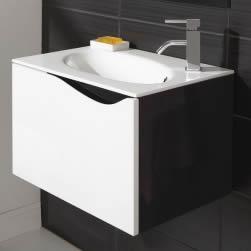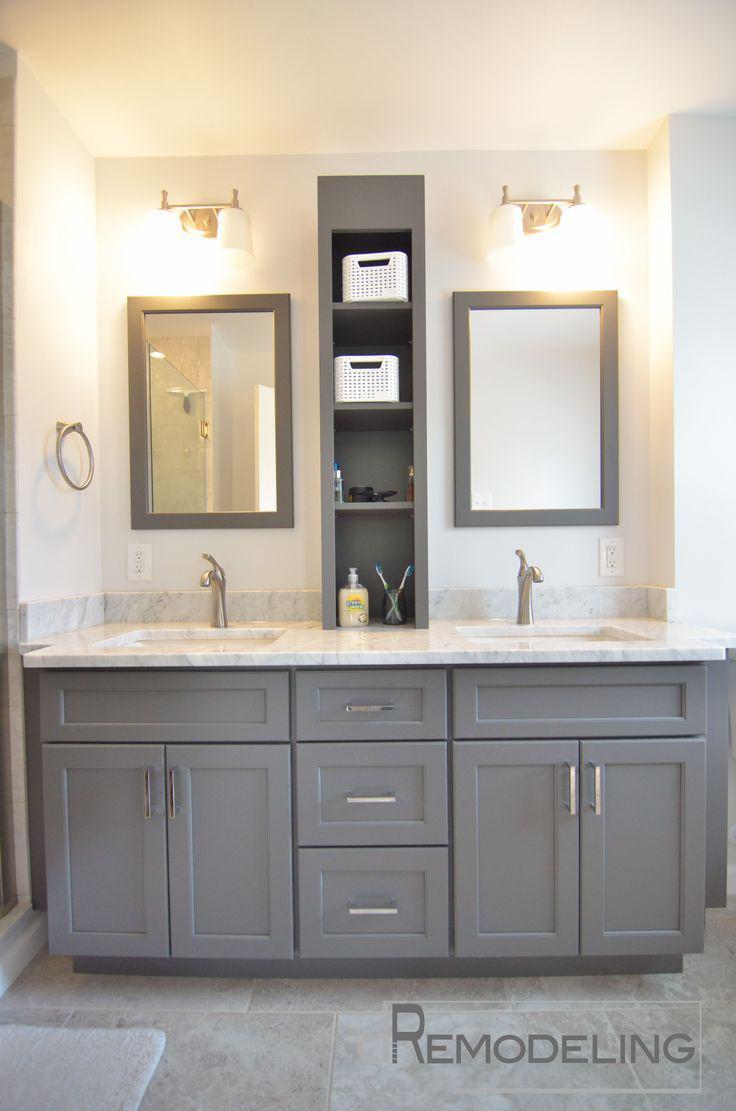The first image is the image on the left, the second image is the image on the right. Considering the images on both sides, is "One of the sinks is inset in a rectangle above metal legs." valid? Answer yes or no. No. 